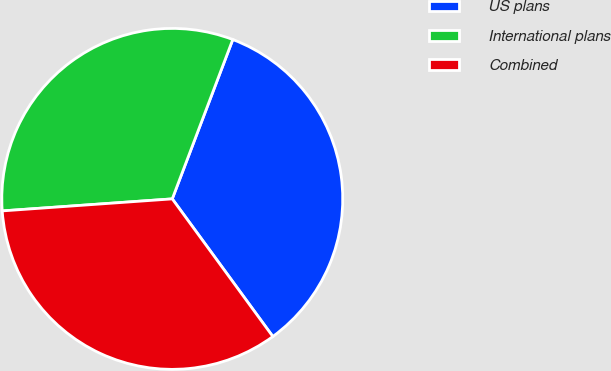Convert chart. <chart><loc_0><loc_0><loc_500><loc_500><pie_chart><fcel>US plans<fcel>International plans<fcel>Combined<nl><fcel>34.18%<fcel>31.9%<fcel>33.92%<nl></chart> 